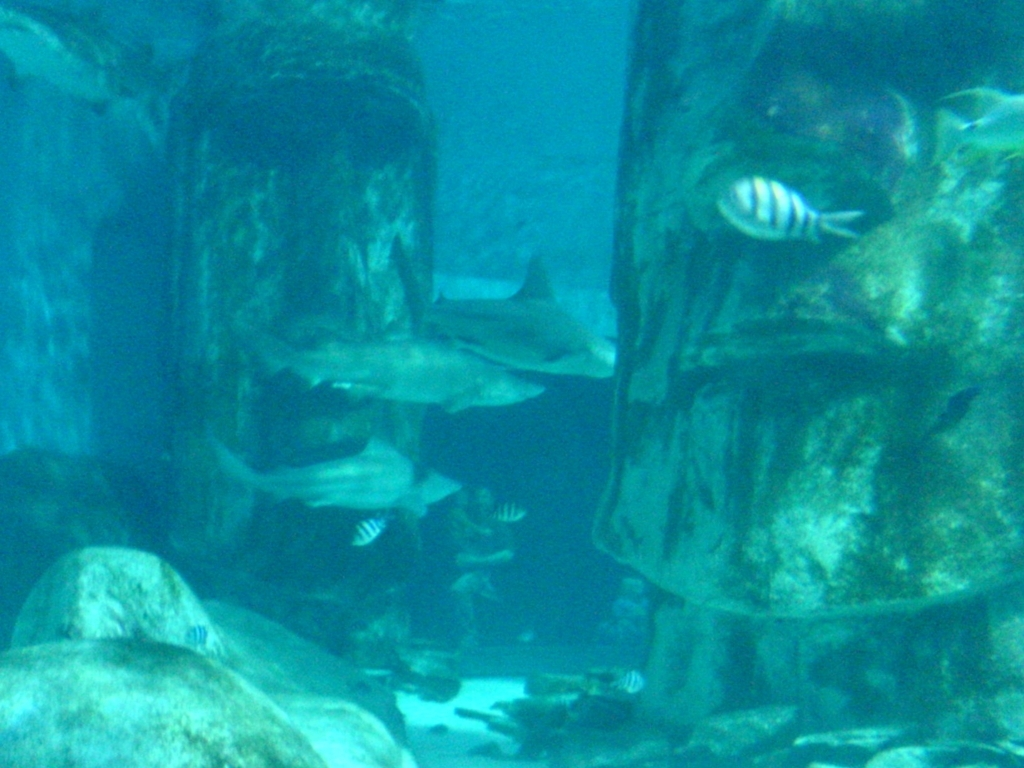Is the quality of this image poor? While the image may appear somewhat blurry, possibly due to the medium of water and low lighting conditions, it may not be fair to categorize the quality as poor without consideration of the challenging environment in which it was taken. The context is essential, and the image still captures the essence of underwater life, showcasing the habitat and the creatures within. 